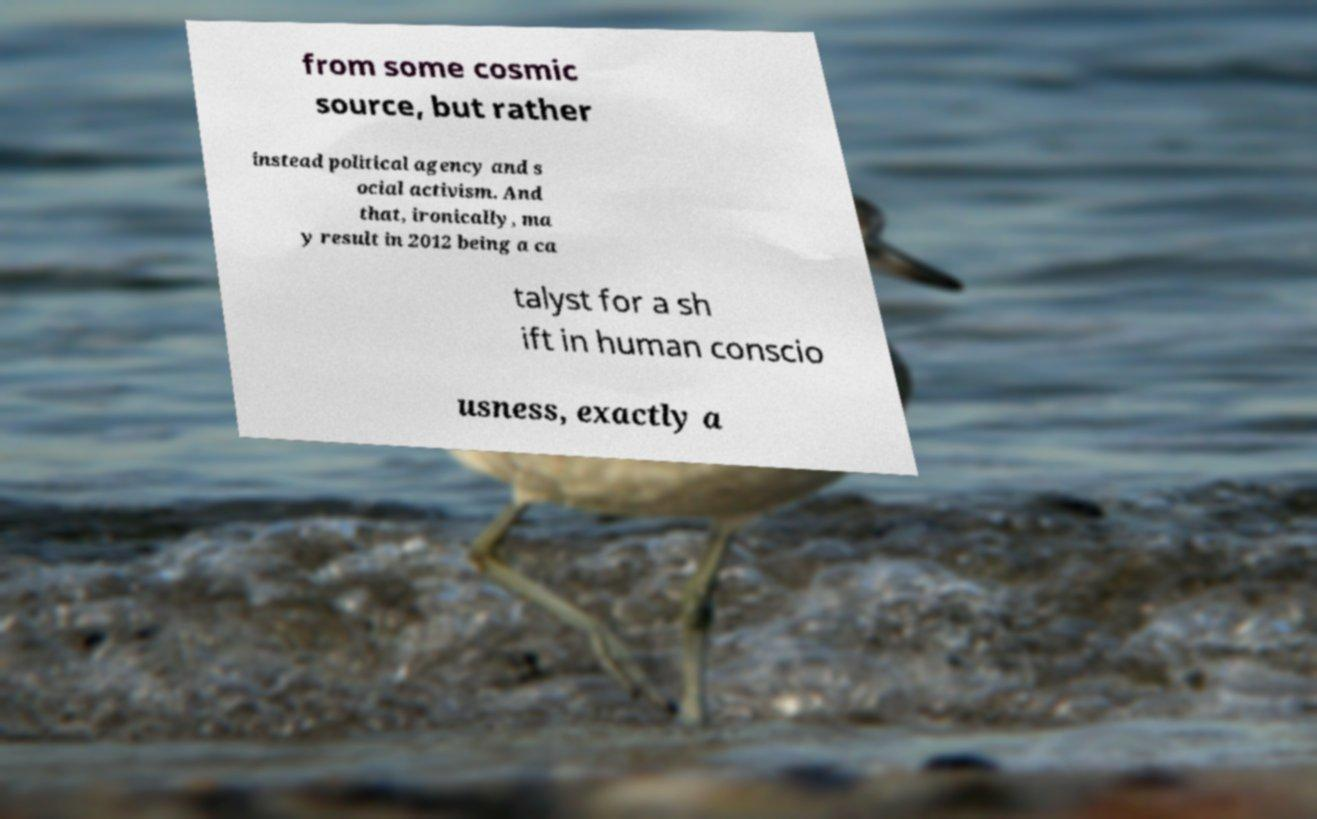For documentation purposes, I need the text within this image transcribed. Could you provide that? from some cosmic source, but rather instead political agency and s ocial activism. And that, ironically, ma y result in 2012 being a ca talyst for a sh ift in human conscio usness, exactly a 